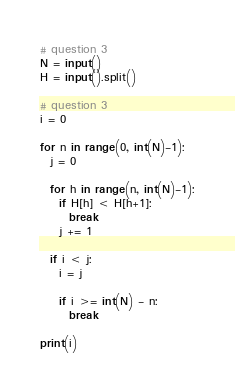<code> <loc_0><loc_0><loc_500><loc_500><_Python_># question 3
N = input()
H = input().split()

# question 3
i = 0

for n in range(0, int(N)-1):
  j = 0
  
  for h in range(n, int(N)-1):
    if H[h] < H[h+1]:
      break
    j += 1      
  
  if i < j:
    i = j
    
    if i >= int(N) - n:
      break
    
print(i)</code> 